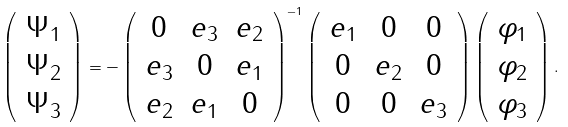Convert formula to latex. <formula><loc_0><loc_0><loc_500><loc_500>\left ( \begin{array} { c } \Psi _ { 1 } \\ \Psi _ { 2 } \\ \Psi _ { 3 } \\ \end{array} \right ) = - \left ( \begin{array} { c c c } 0 & e _ { 3 } & e _ { 2 } \\ e _ { 3 } & 0 & e _ { 1 } \\ e _ { 2 } & e _ { 1 } & 0 \\ \end{array} \right ) ^ { - 1 } \left ( \begin{array} { c c c } e _ { 1 } & 0 & 0 \\ 0 & e _ { 2 } & 0 \\ 0 & 0 & e _ { 3 } \\ \end{array} \right ) \left ( \begin{array} { c } \varphi _ { 1 } \\ \varphi _ { 2 } \\ \varphi _ { 3 } \\ \end{array} \right ) .</formula> 